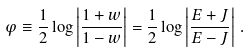Convert formula to latex. <formula><loc_0><loc_0><loc_500><loc_500>\varphi \equiv \frac { 1 } { 2 } \log \left | \frac { 1 + w } { 1 - w } \right | = { \frac { 1 } { 2 } } \log \left | \frac { E + J } { E - J } \right | \, .</formula> 